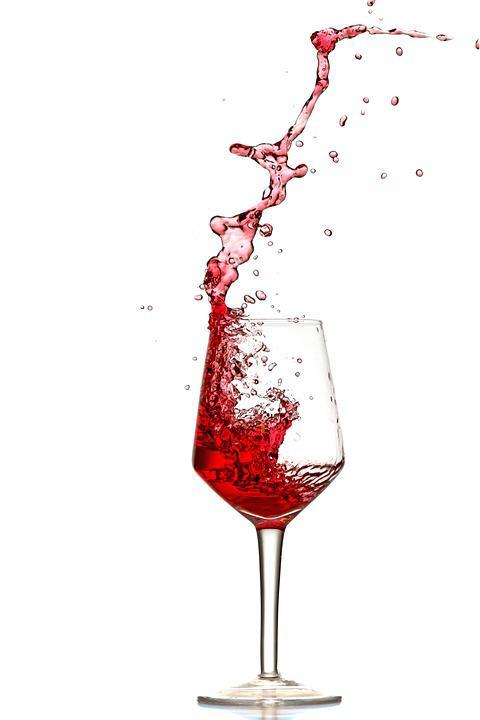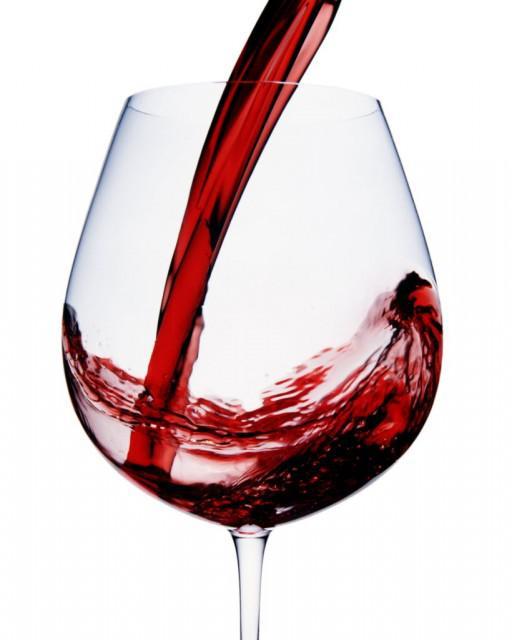The first image is the image on the left, the second image is the image on the right. Analyze the images presented: Is the assertion "The neck of the bottle is near a glass." valid? Answer yes or no. No. 